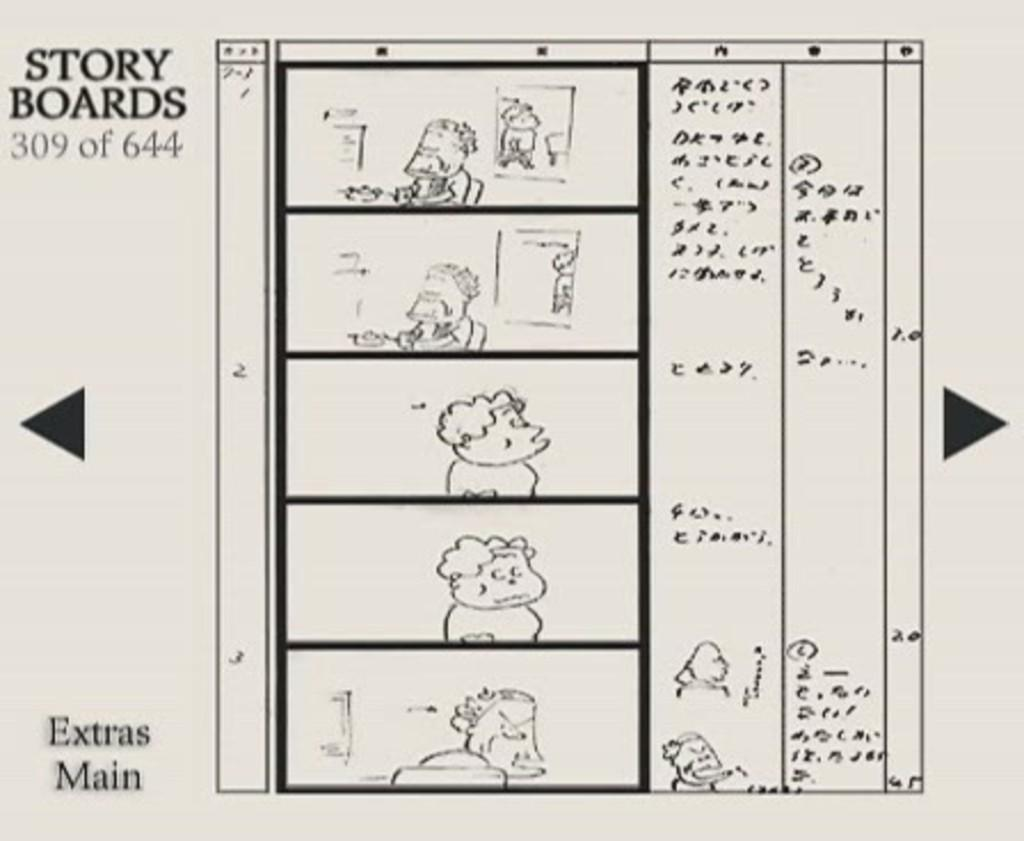What is the main object in the image? There is a white paper in the image. What is depicted on the paper? Cartoons are drawn on the paper. Is there any text on the paper? Yes, there is a small quote written on the left side of the paper. How many balls are bouncing around the cartoons on the paper? There are no balls present in the image; it only features cartoons and a quote on a white paper. 